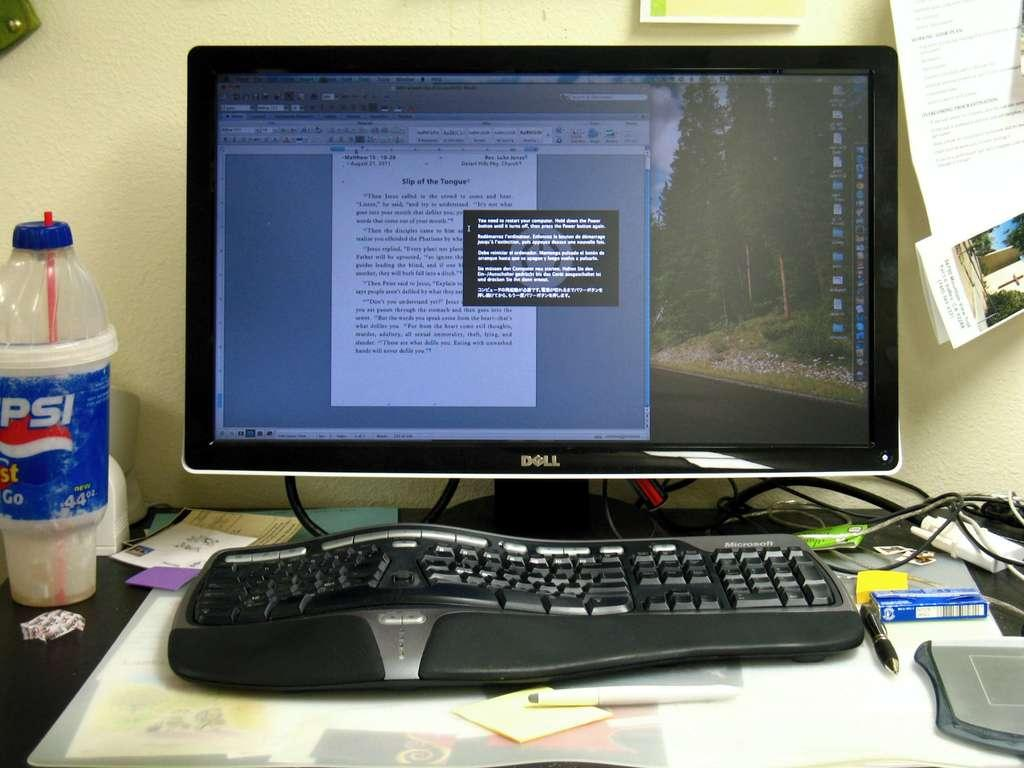What electronic device is visible in the image? There is a monitor in the image. What is used for typing on the monitor? There is a keyboard in the image. What writing instrument is present in the image? There is a pen in the image. What object is used for storing items? There is a box in the image. What is used for controlling the cursor on the monitor? There is a mouse pad in the image. What connects the devices in the image? There are cables in the image. What is being written on in the image? There is a paper in the image. What is being used to drink from the bottle? There is a straw in the image. Where are the objects located? The objects are on a table. What is visible on the wall in the background? There is paper stuck to the wall in the background. How many dogs are sitting on the table in the image? There are no dogs present in the image; the objects are on a table. What type of whip is being used to control the monitor in the image? There is no whip present in the image, and the monitor is controlled using a mouse or keyboard. 